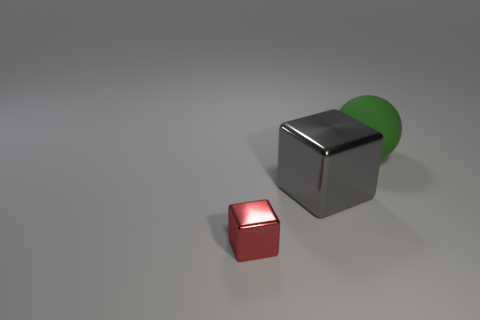What is the material of the gray block that is the same size as the green sphere?
Your answer should be very brief. Metal. Does the object behind the large metal thing have the same shape as the tiny red thing?
Your answer should be compact. No. Is the number of green matte balls that are right of the large metallic thing greater than the number of tiny red blocks that are to the right of the big green rubber ball?
Your answer should be compact. Yes. What number of balls are the same material as the small block?
Give a very brief answer. 0. Do the red shiny object and the green matte thing have the same size?
Offer a very short reply. No. The tiny metallic object is what color?
Keep it short and to the point. Red. What number of objects are either small yellow matte cubes or shiny blocks?
Give a very brief answer. 2. Is there a big purple rubber object of the same shape as the large green rubber thing?
Your response must be concise. No. Do the large thing in front of the large green matte object and the matte ball have the same color?
Provide a succinct answer. No. There is a object right of the metal object on the right side of the tiny red object; what is its shape?
Your response must be concise. Sphere. 